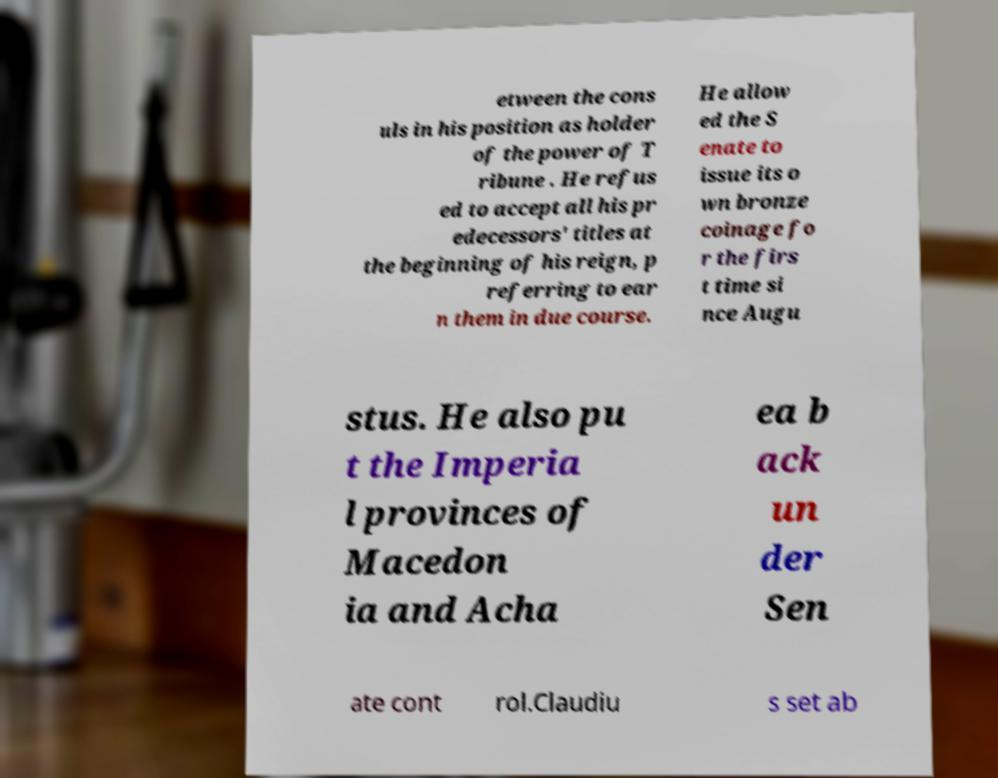I need the written content from this picture converted into text. Can you do that? etween the cons uls in his position as holder of the power of T ribune . He refus ed to accept all his pr edecessors' titles at the beginning of his reign, p referring to ear n them in due course. He allow ed the S enate to issue its o wn bronze coinage fo r the firs t time si nce Augu stus. He also pu t the Imperia l provinces of Macedon ia and Acha ea b ack un der Sen ate cont rol.Claudiu s set ab 